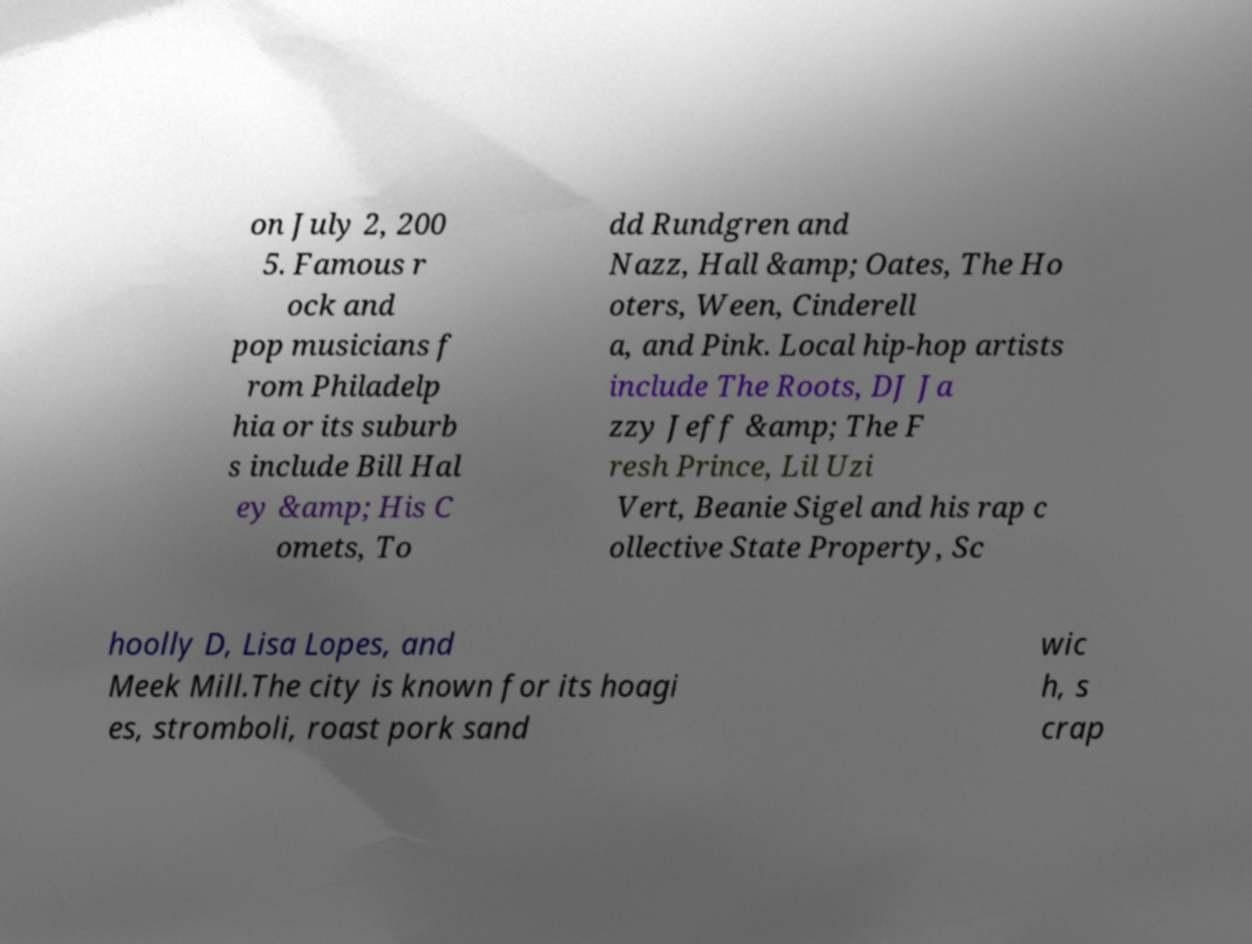For documentation purposes, I need the text within this image transcribed. Could you provide that? on July 2, 200 5. Famous r ock and pop musicians f rom Philadelp hia or its suburb s include Bill Hal ey &amp; His C omets, To dd Rundgren and Nazz, Hall &amp; Oates, The Ho oters, Ween, Cinderell a, and Pink. Local hip-hop artists include The Roots, DJ Ja zzy Jeff &amp; The F resh Prince, Lil Uzi Vert, Beanie Sigel and his rap c ollective State Property, Sc hoolly D, Lisa Lopes, and Meek Mill.The city is known for its hoagi es, stromboli, roast pork sand wic h, s crap 